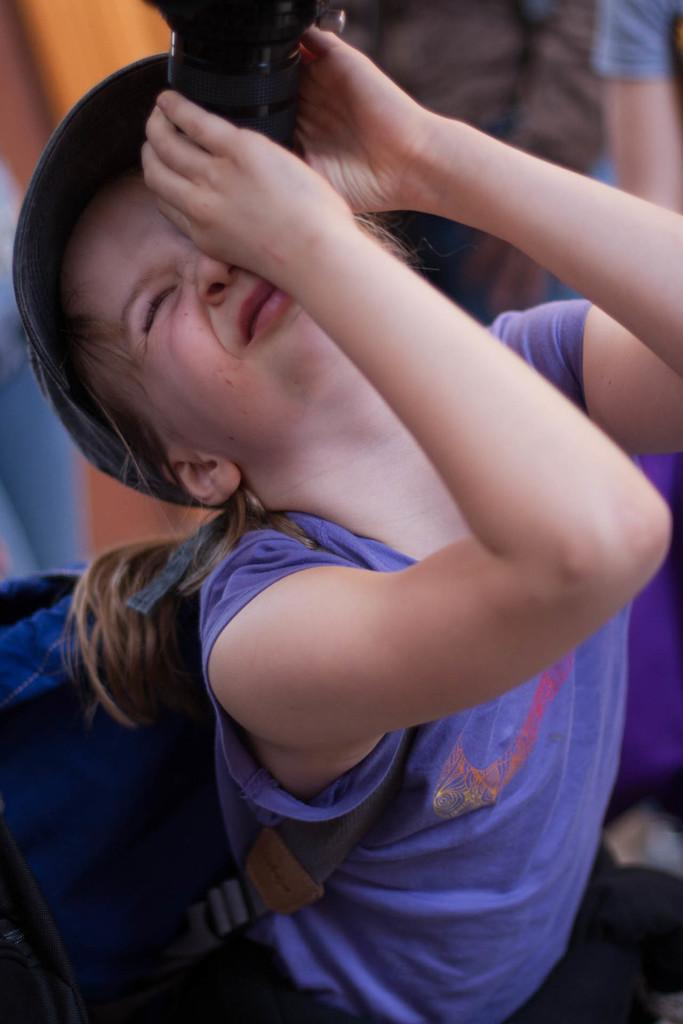Who is the main subject in the image? There is a girl in the image. What is the girl doing in the image? The girl is standing with a bag and holding an object. Can you describe the background of the image? The background of the image is blurred. Are there any other people visible in the image? Yes, there is a person's hand visible on the right side of the image. What type of needle is being used by the girl in the image? There is no needle present in the image. What kind of stem can be seen growing from the girl's hand in the image? There is no stem growing from the girl's hand in the image. 